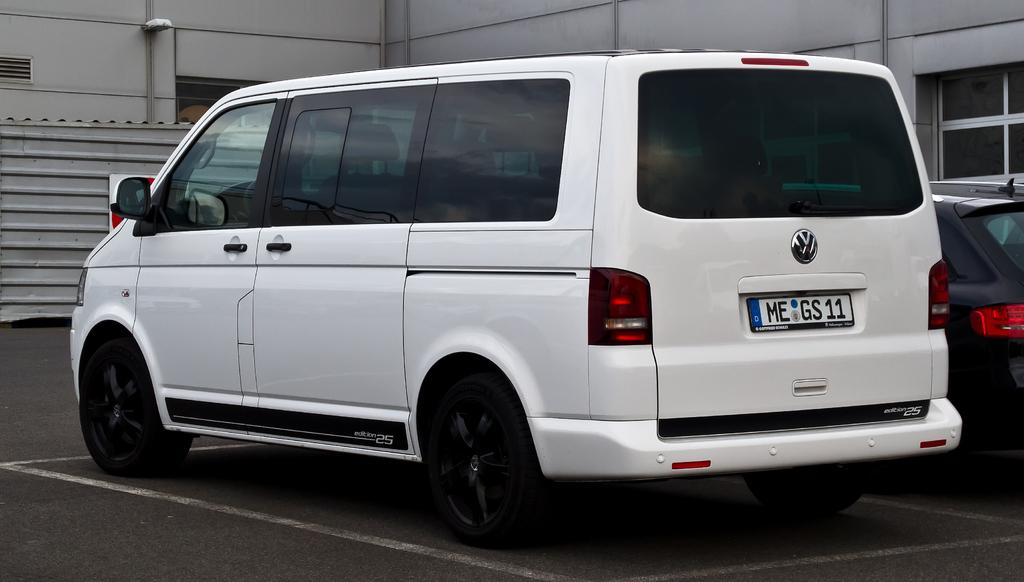Provide a one-sentence caption for the provided image. A white Volkswagen van sitting in a parking lot by a grey building. 